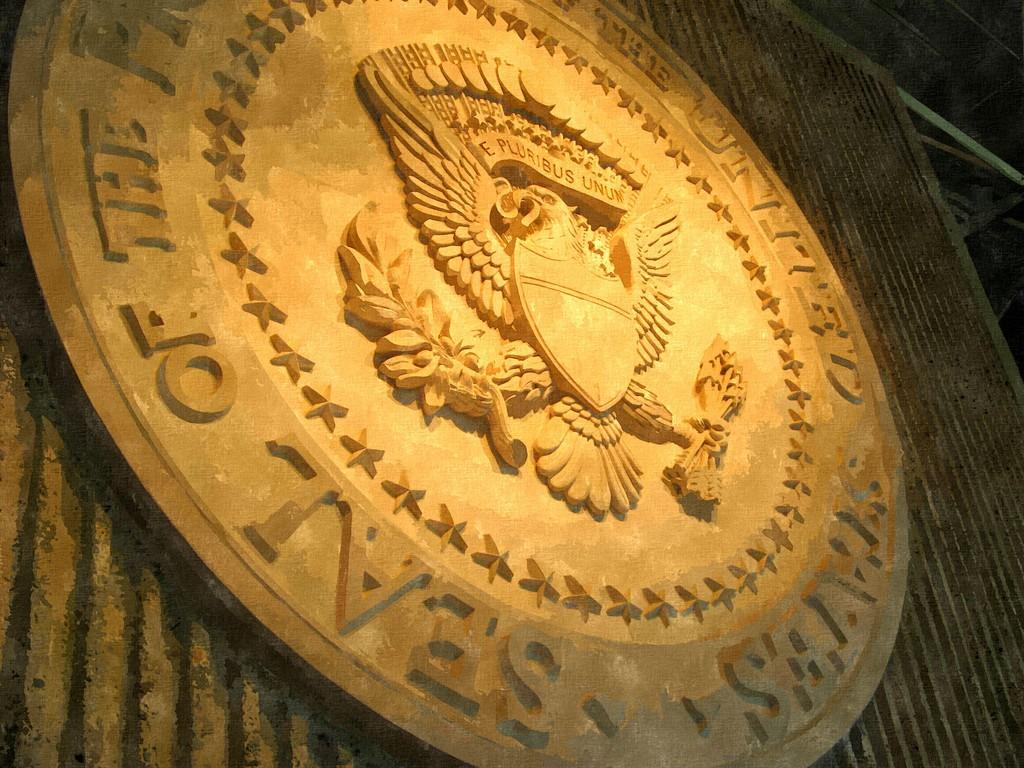Provide a one-sentence caption for the provided image. The Seal of the President of the United States looks to be carved from wood. 